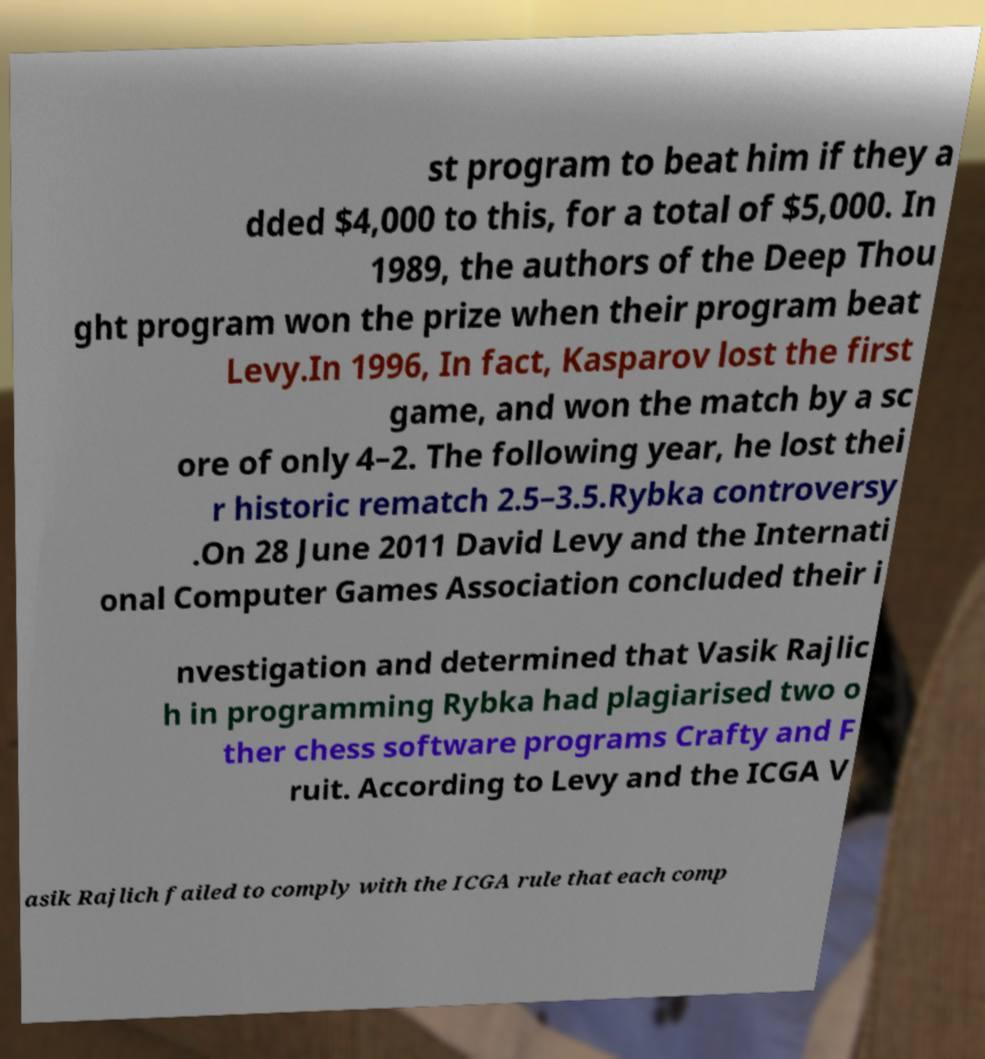Please identify and transcribe the text found in this image. st program to beat him if they a dded $4,000 to this, for a total of $5,000. In 1989, the authors of the Deep Thou ght program won the prize when their program beat Levy.In 1996, In fact, Kasparov lost the first game, and won the match by a sc ore of only 4–2. The following year, he lost thei r historic rematch 2.5–3.5.Rybka controversy .On 28 June 2011 David Levy and the Internati onal Computer Games Association concluded their i nvestigation and determined that Vasik Rajlic h in programming Rybka had plagiarised two o ther chess software programs Crafty and F ruit. According to Levy and the ICGA V asik Rajlich failed to comply with the ICGA rule that each comp 